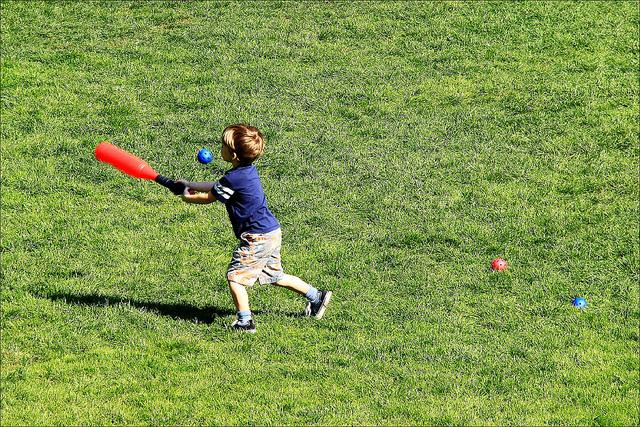Why does the boy have his arms out?

Choices:
A) swing
B) break fall
C) wave
D) reach swing 